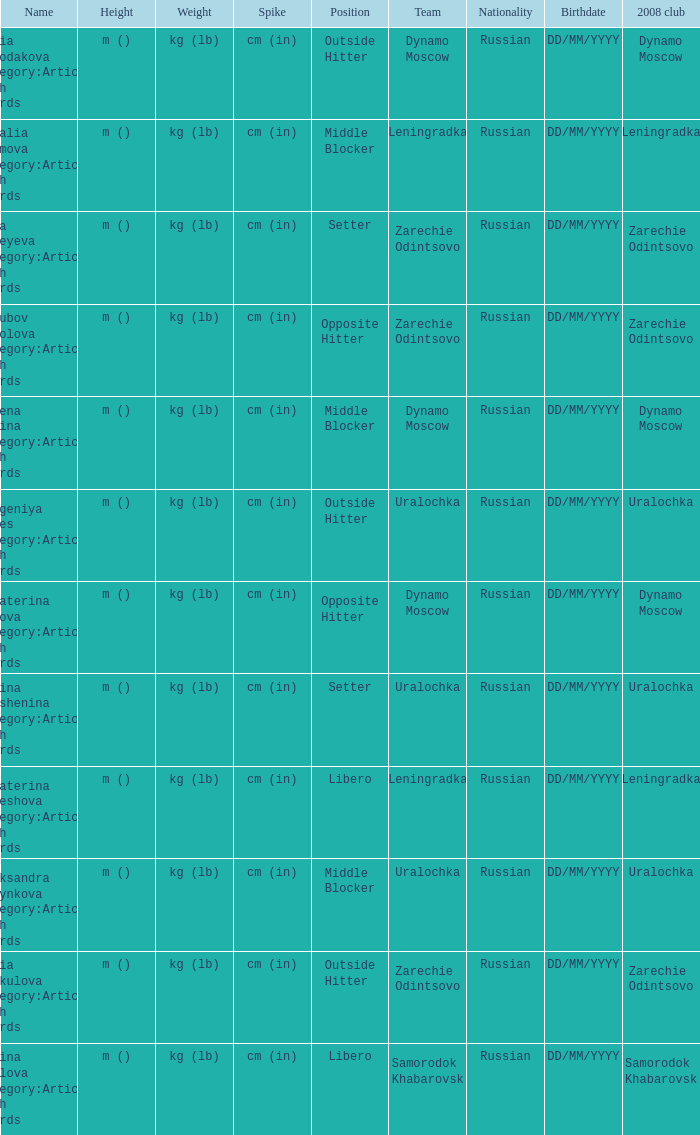What is the name when the 2008 club is zarechie odintsovo? Olga Fateyeva Category:Articles with hCards, Lioubov Sokolova Category:Articles with hCards, Yulia Merkulova Category:Articles with hCards. 